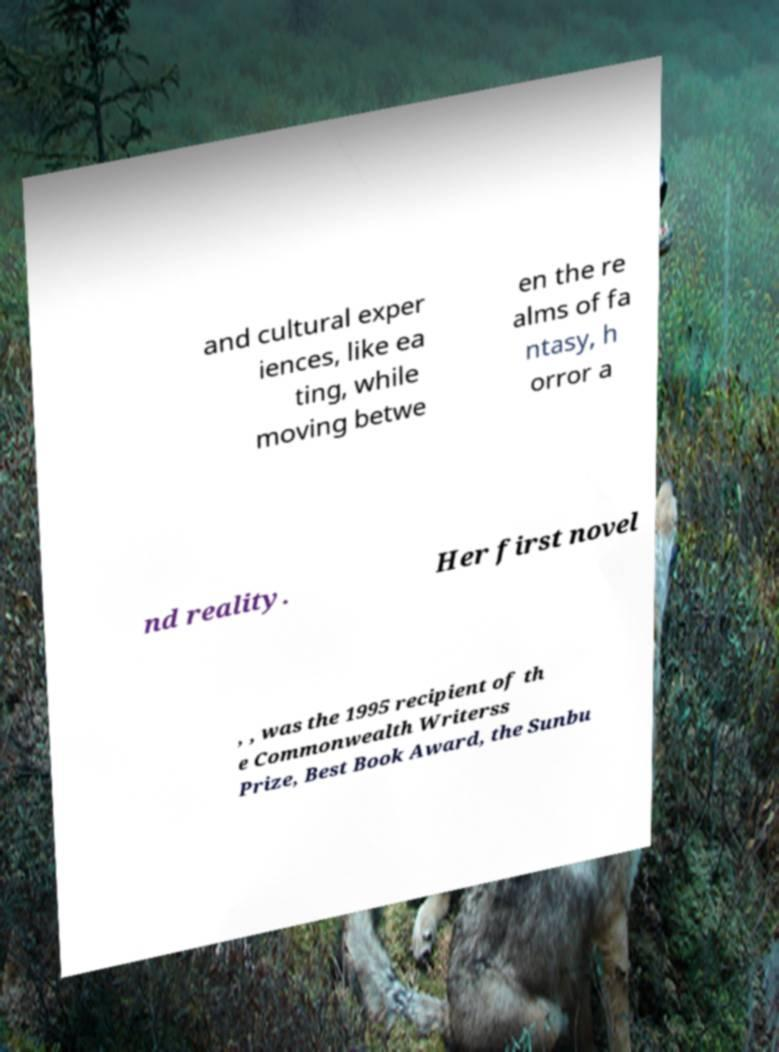Could you assist in decoding the text presented in this image and type it out clearly? and cultural exper iences, like ea ting, while moving betwe en the re alms of fa ntasy, h orror a nd reality. Her first novel , , was the 1995 recipient of th e Commonwealth Writerss Prize, Best Book Award, the Sunbu 